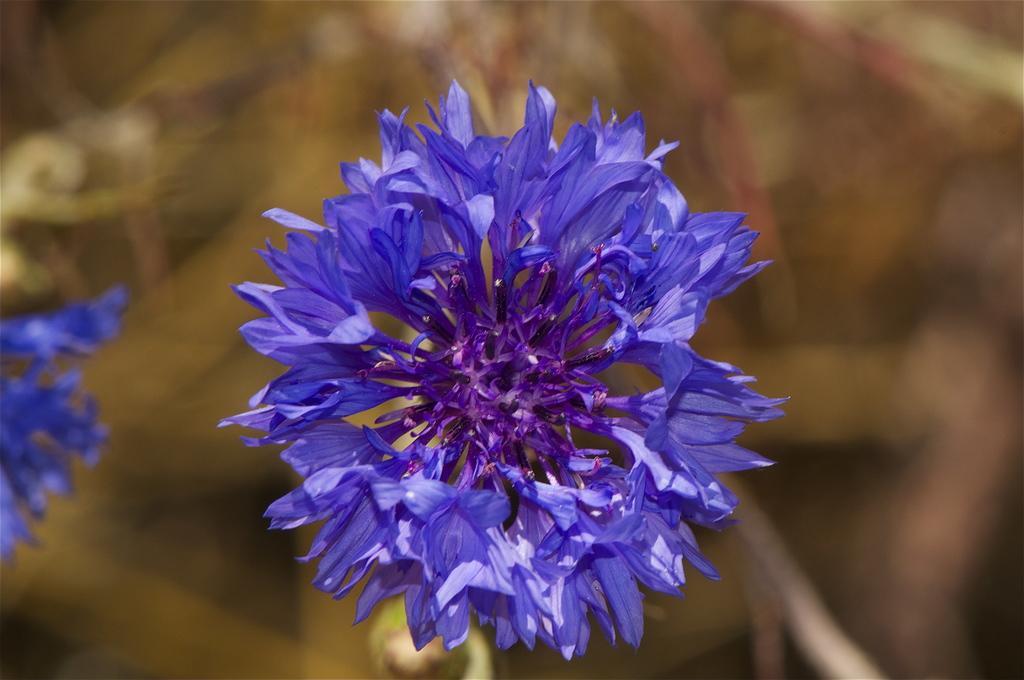In one or two sentences, can you explain what this image depicts? There is a beautiful purple flower, and the background of the flower is blue. 